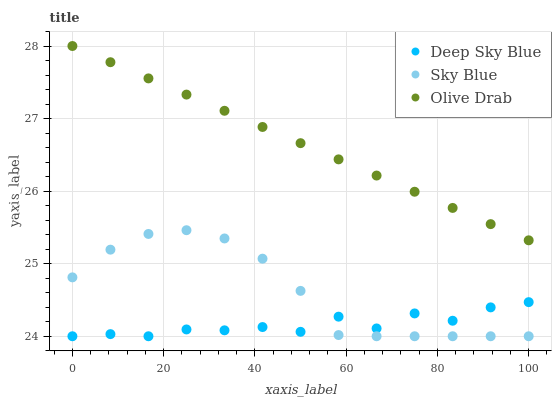Does Deep Sky Blue have the minimum area under the curve?
Answer yes or no. Yes. Does Olive Drab have the maximum area under the curve?
Answer yes or no. Yes. Does Olive Drab have the minimum area under the curve?
Answer yes or no. No. Does Deep Sky Blue have the maximum area under the curve?
Answer yes or no. No. Is Olive Drab the smoothest?
Answer yes or no. Yes. Is Deep Sky Blue the roughest?
Answer yes or no. Yes. Is Deep Sky Blue the smoothest?
Answer yes or no. No. Is Olive Drab the roughest?
Answer yes or no. No. Does Sky Blue have the lowest value?
Answer yes or no. Yes. Does Olive Drab have the lowest value?
Answer yes or no. No. Does Olive Drab have the highest value?
Answer yes or no. Yes. Does Deep Sky Blue have the highest value?
Answer yes or no. No. Is Deep Sky Blue less than Olive Drab?
Answer yes or no. Yes. Is Olive Drab greater than Sky Blue?
Answer yes or no. Yes. Does Sky Blue intersect Deep Sky Blue?
Answer yes or no. Yes. Is Sky Blue less than Deep Sky Blue?
Answer yes or no. No. Is Sky Blue greater than Deep Sky Blue?
Answer yes or no. No. Does Deep Sky Blue intersect Olive Drab?
Answer yes or no. No. 